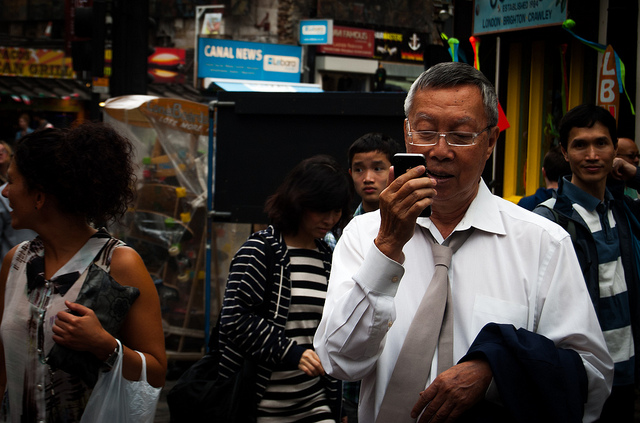Identify the text displayed in this image. NEWS LB 